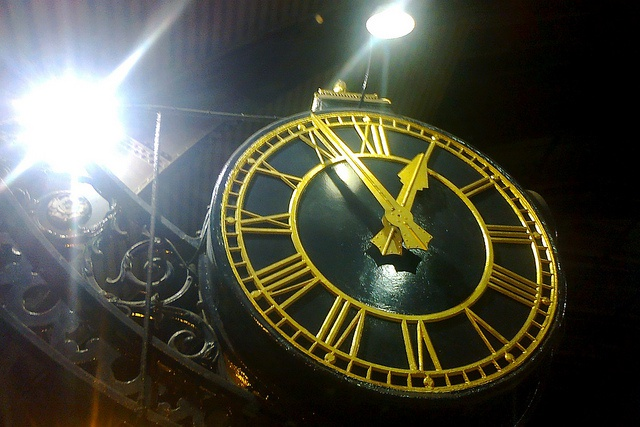Describe the objects in this image and their specific colors. I can see a clock in gray, black, and olive tones in this image. 